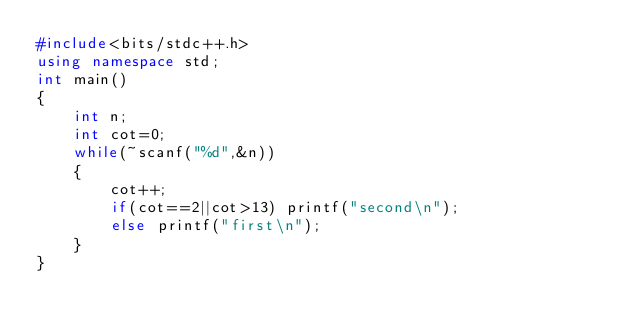Convert code to text. <code><loc_0><loc_0><loc_500><loc_500><_C++_>#include<bits/stdc++.h>
using namespace std;
int main()
{
    int n;
    int cot=0;
    while(~scanf("%d",&n))
    {
        cot++;
        if(cot==2||cot>13) printf("second\n");
        else printf("first\n");
    }
}
</code> 